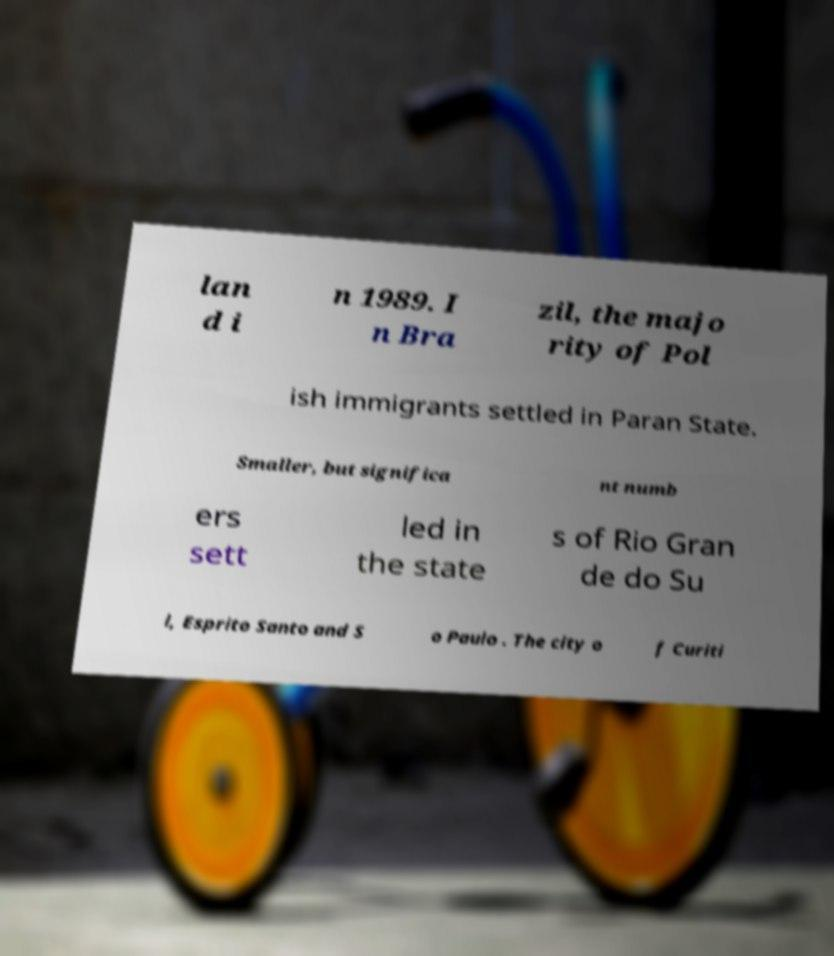Could you extract and type out the text from this image? lan d i n 1989. I n Bra zil, the majo rity of Pol ish immigrants settled in Paran State. Smaller, but significa nt numb ers sett led in the state s of Rio Gran de do Su l, Esprito Santo and S o Paulo . The city o f Curiti 